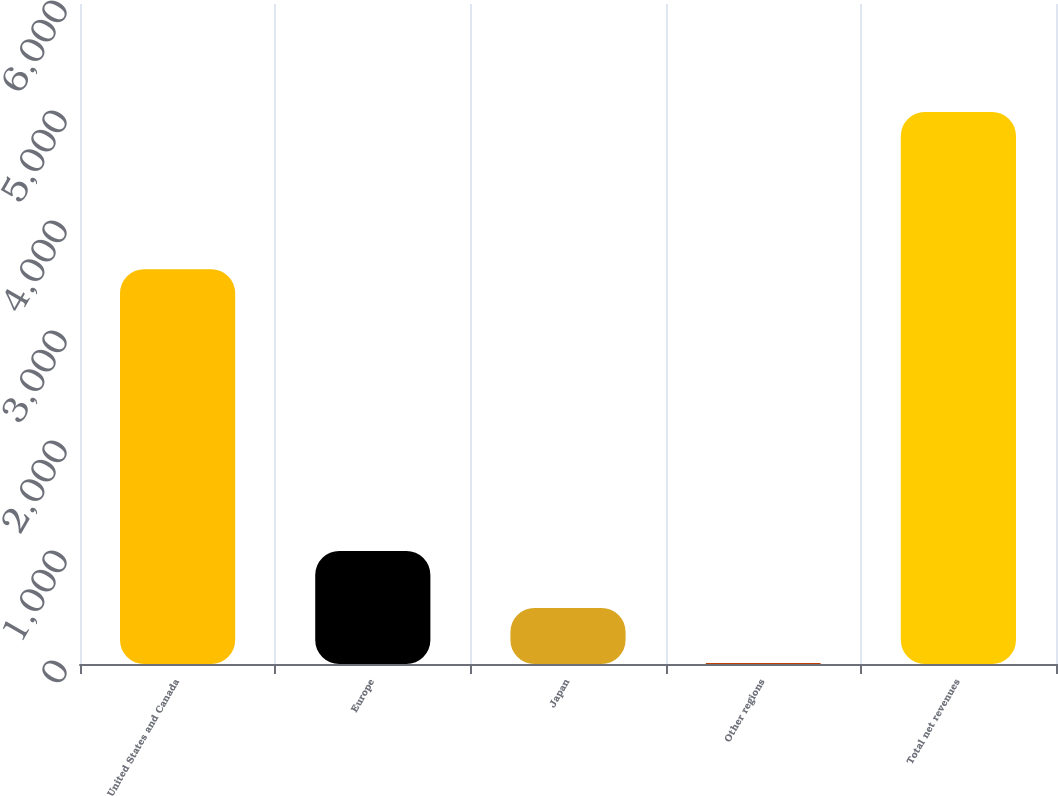<chart> <loc_0><loc_0><loc_500><loc_500><bar_chart><fcel>United States and Canada<fcel>Europe<fcel>Japan<fcel>Other regions<fcel>Total net revenues<nl><fcel>3589.3<fcel>1028.4<fcel>509.63<fcel>8.6<fcel>5018.9<nl></chart> 